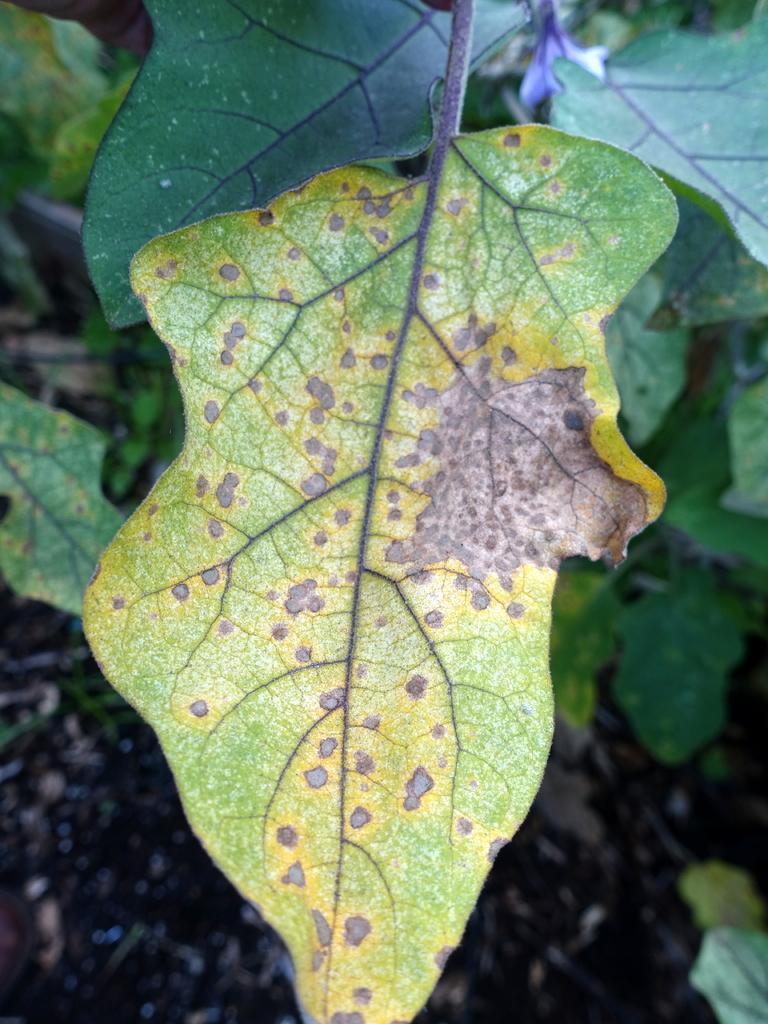Could you give a brief overview of what you see in this image? In this image I can see number of green colour leaves. 